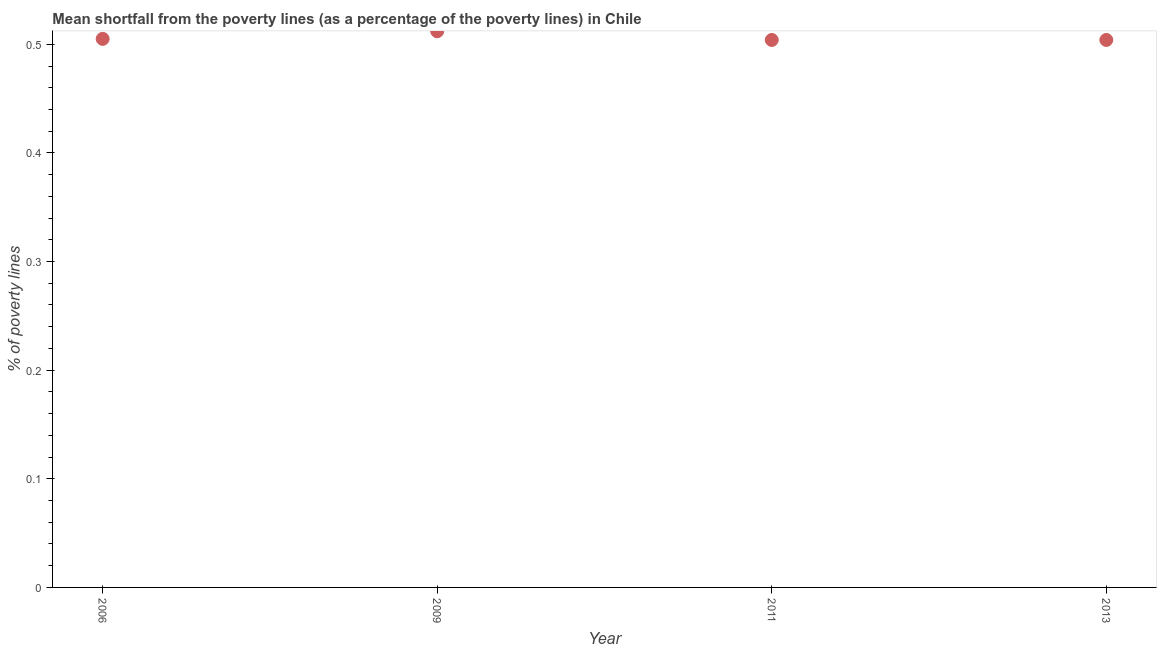What is the poverty gap at national poverty lines in 2006?
Your answer should be very brief. 0.51. Across all years, what is the maximum poverty gap at national poverty lines?
Ensure brevity in your answer.  0.51. Across all years, what is the minimum poverty gap at national poverty lines?
Make the answer very short. 0.5. In which year was the poverty gap at national poverty lines minimum?
Make the answer very short. 2011. What is the sum of the poverty gap at national poverty lines?
Keep it short and to the point. 2.02. What is the difference between the poverty gap at national poverty lines in 2006 and 2011?
Keep it short and to the point. 0. What is the average poverty gap at national poverty lines per year?
Provide a succinct answer. 0.51. What is the median poverty gap at national poverty lines?
Provide a short and direct response. 0.5. In how many years, is the poverty gap at national poverty lines greater than 0.28 %?
Keep it short and to the point. 4. What is the ratio of the poverty gap at national poverty lines in 2006 to that in 2013?
Give a very brief answer. 1. What is the difference between the highest and the second highest poverty gap at national poverty lines?
Offer a terse response. 0.01. What is the difference between the highest and the lowest poverty gap at national poverty lines?
Give a very brief answer. 0.01. Does the poverty gap at national poverty lines monotonically increase over the years?
Provide a short and direct response. No. How many dotlines are there?
Your answer should be very brief. 1. How many years are there in the graph?
Your response must be concise. 4. Are the values on the major ticks of Y-axis written in scientific E-notation?
Make the answer very short. No. What is the title of the graph?
Make the answer very short. Mean shortfall from the poverty lines (as a percentage of the poverty lines) in Chile. What is the label or title of the Y-axis?
Provide a short and direct response. % of poverty lines. What is the % of poverty lines in 2006?
Offer a very short reply. 0.51. What is the % of poverty lines in 2009?
Offer a very short reply. 0.51. What is the % of poverty lines in 2011?
Your response must be concise. 0.5. What is the % of poverty lines in 2013?
Provide a succinct answer. 0.5. What is the difference between the % of poverty lines in 2006 and 2009?
Ensure brevity in your answer.  -0.01. What is the difference between the % of poverty lines in 2006 and 2011?
Provide a succinct answer. 0. What is the difference between the % of poverty lines in 2009 and 2011?
Your answer should be compact. 0.01. What is the difference between the % of poverty lines in 2009 and 2013?
Give a very brief answer. 0.01. What is the difference between the % of poverty lines in 2011 and 2013?
Provide a succinct answer. 0. What is the ratio of the % of poverty lines in 2006 to that in 2009?
Your answer should be compact. 0.99. What is the ratio of the % of poverty lines in 2006 to that in 2011?
Offer a very short reply. 1. What is the ratio of the % of poverty lines in 2009 to that in 2013?
Make the answer very short. 1.02. 